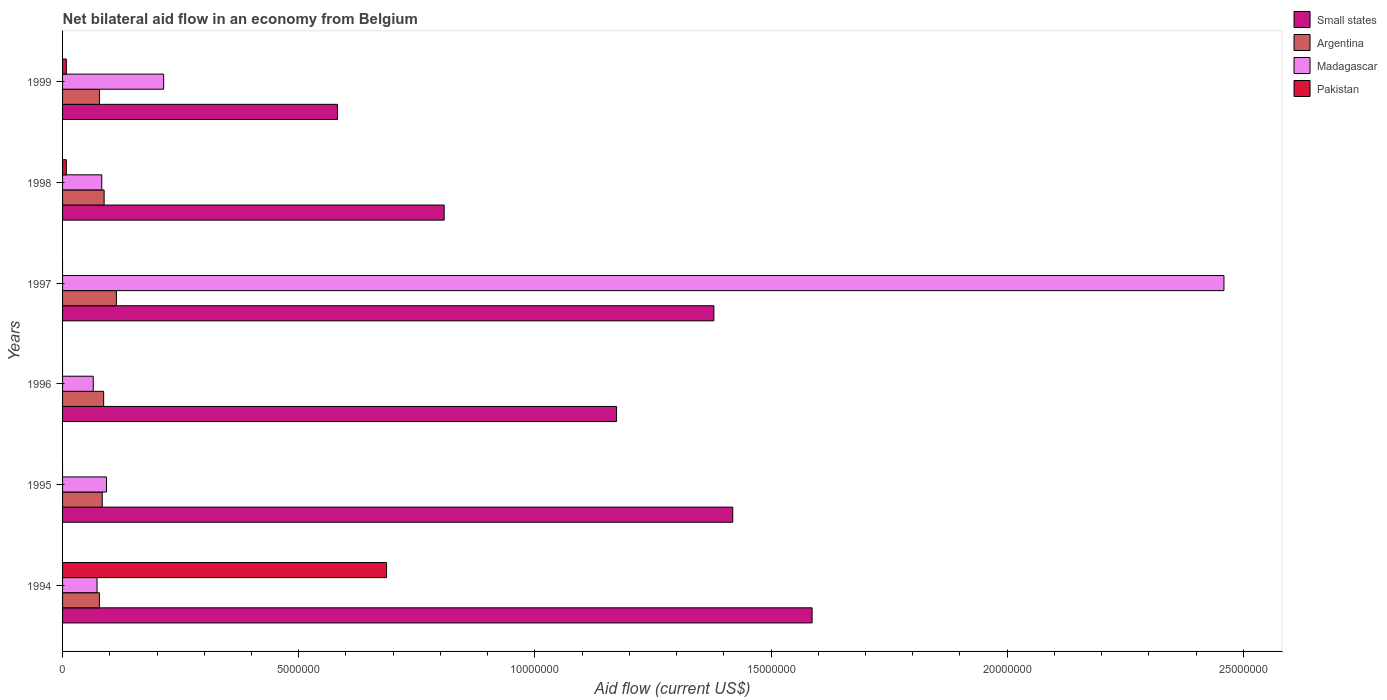How many groups of bars are there?
Your answer should be very brief. 6. How many bars are there on the 1st tick from the top?
Give a very brief answer. 4. In how many cases, is the number of bars for a given year not equal to the number of legend labels?
Make the answer very short. 3. What is the net bilateral aid flow in Argentina in 1997?
Give a very brief answer. 1.14e+06. Across all years, what is the maximum net bilateral aid flow in Madagascar?
Ensure brevity in your answer.  2.46e+07. Across all years, what is the minimum net bilateral aid flow in Madagascar?
Give a very brief answer. 6.50e+05. What is the total net bilateral aid flow in Small states in the graph?
Provide a succinct answer. 6.95e+07. What is the difference between the net bilateral aid flow in Madagascar in 1997 and that in 1998?
Offer a very short reply. 2.38e+07. What is the difference between the net bilateral aid flow in Pakistan in 1998 and the net bilateral aid flow in Argentina in 1997?
Your answer should be very brief. -1.06e+06. What is the average net bilateral aid flow in Argentina per year?
Provide a succinct answer. 8.82e+05. In the year 1994, what is the difference between the net bilateral aid flow in Madagascar and net bilateral aid flow in Argentina?
Ensure brevity in your answer.  -5.00e+04. What is the ratio of the net bilateral aid flow in Madagascar in 1997 to that in 1998?
Give a very brief answer. 29.63. Is the net bilateral aid flow in Madagascar in 1996 less than that in 1998?
Your answer should be compact. Yes. What is the difference between the highest and the second highest net bilateral aid flow in Small states?
Offer a very short reply. 1.68e+06. What is the difference between the highest and the lowest net bilateral aid flow in Small states?
Your answer should be very brief. 1.00e+07. Is the sum of the net bilateral aid flow in Small states in 1996 and 1997 greater than the maximum net bilateral aid flow in Madagascar across all years?
Ensure brevity in your answer.  Yes. How many bars are there?
Offer a terse response. 21. What is the difference between two consecutive major ticks on the X-axis?
Offer a very short reply. 5.00e+06. Does the graph contain any zero values?
Offer a very short reply. Yes. Does the graph contain grids?
Ensure brevity in your answer.  No. Where does the legend appear in the graph?
Make the answer very short. Top right. How many legend labels are there?
Keep it short and to the point. 4. How are the legend labels stacked?
Make the answer very short. Vertical. What is the title of the graph?
Your response must be concise. Net bilateral aid flow in an economy from Belgium. What is the Aid flow (current US$) of Small states in 1994?
Your response must be concise. 1.59e+07. What is the Aid flow (current US$) of Argentina in 1994?
Your answer should be very brief. 7.80e+05. What is the Aid flow (current US$) of Madagascar in 1994?
Offer a very short reply. 7.30e+05. What is the Aid flow (current US$) in Pakistan in 1994?
Make the answer very short. 6.86e+06. What is the Aid flow (current US$) of Small states in 1995?
Provide a short and direct response. 1.42e+07. What is the Aid flow (current US$) in Argentina in 1995?
Ensure brevity in your answer.  8.40e+05. What is the Aid flow (current US$) in Madagascar in 1995?
Your answer should be very brief. 9.30e+05. What is the Aid flow (current US$) in Small states in 1996?
Give a very brief answer. 1.17e+07. What is the Aid flow (current US$) in Argentina in 1996?
Provide a short and direct response. 8.70e+05. What is the Aid flow (current US$) of Madagascar in 1996?
Provide a succinct answer. 6.50e+05. What is the Aid flow (current US$) in Small states in 1997?
Give a very brief answer. 1.38e+07. What is the Aid flow (current US$) of Argentina in 1997?
Ensure brevity in your answer.  1.14e+06. What is the Aid flow (current US$) of Madagascar in 1997?
Make the answer very short. 2.46e+07. What is the Aid flow (current US$) of Pakistan in 1997?
Make the answer very short. 0. What is the Aid flow (current US$) of Small states in 1998?
Your response must be concise. 8.08e+06. What is the Aid flow (current US$) of Argentina in 1998?
Offer a very short reply. 8.80e+05. What is the Aid flow (current US$) in Madagascar in 1998?
Your answer should be very brief. 8.30e+05. What is the Aid flow (current US$) of Pakistan in 1998?
Make the answer very short. 8.00e+04. What is the Aid flow (current US$) in Small states in 1999?
Make the answer very short. 5.82e+06. What is the Aid flow (current US$) of Argentina in 1999?
Keep it short and to the point. 7.80e+05. What is the Aid flow (current US$) in Madagascar in 1999?
Ensure brevity in your answer.  2.14e+06. What is the Aid flow (current US$) of Pakistan in 1999?
Your answer should be very brief. 8.00e+04. Across all years, what is the maximum Aid flow (current US$) in Small states?
Provide a succinct answer. 1.59e+07. Across all years, what is the maximum Aid flow (current US$) of Argentina?
Offer a very short reply. 1.14e+06. Across all years, what is the maximum Aid flow (current US$) in Madagascar?
Your response must be concise. 2.46e+07. Across all years, what is the maximum Aid flow (current US$) of Pakistan?
Offer a very short reply. 6.86e+06. Across all years, what is the minimum Aid flow (current US$) in Small states?
Your answer should be very brief. 5.82e+06. Across all years, what is the minimum Aid flow (current US$) in Argentina?
Keep it short and to the point. 7.80e+05. Across all years, what is the minimum Aid flow (current US$) of Madagascar?
Offer a terse response. 6.50e+05. Across all years, what is the minimum Aid flow (current US$) of Pakistan?
Your answer should be very brief. 0. What is the total Aid flow (current US$) in Small states in the graph?
Your response must be concise. 6.95e+07. What is the total Aid flow (current US$) in Argentina in the graph?
Provide a succinct answer. 5.29e+06. What is the total Aid flow (current US$) of Madagascar in the graph?
Your response must be concise. 2.99e+07. What is the total Aid flow (current US$) in Pakistan in the graph?
Make the answer very short. 7.02e+06. What is the difference between the Aid flow (current US$) of Small states in 1994 and that in 1995?
Your answer should be very brief. 1.68e+06. What is the difference between the Aid flow (current US$) of Argentina in 1994 and that in 1995?
Your answer should be compact. -6.00e+04. What is the difference between the Aid flow (current US$) of Madagascar in 1994 and that in 1995?
Provide a succinct answer. -2.00e+05. What is the difference between the Aid flow (current US$) in Small states in 1994 and that in 1996?
Your answer should be very brief. 4.14e+06. What is the difference between the Aid flow (current US$) of Madagascar in 1994 and that in 1996?
Keep it short and to the point. 8.00e+04. What is the difference between the Aid flow (current US$) in Small states in 1994 and that in 1997?
Offer a terse response. 2.08e+06. What is the difference between the Aid flow (current US$) of Argentina in 1994 and that in 1997?
Keep it short and to the point. -3.60e+05. What is the difference between the Aid flow (current US$) of Madagascar in 1994 and that in 1997?
Your answer should be compact. -2.39e+07. What is the difference between the Aid flow (current US$) in Small states in 1994 and that in 1998?
Make the answer very short. 7.79e+06. What is the difference between the Aid flow (current US$) of Argentina in 1994 and that in 1998?
Give a very brief answer. -1.00e+05. What is the difference between the Aid flow (current US$) of Pakistan in 1994 and that in 1998?
Provide a succinct answer. 6.78e+06. What is the difference between the Aid flow (current US$) of Small states in 1994 and that in 1999?
Ensure brevity in your answer.  1.00e+07. What is the difference between the Aid flow (current US$) of Madagascar in 1994 and that in 1999?
Your answer should be compact. -1.41e+06. What is the difference between the Aid flow (current US$) of Pakistan in 1994 and that in 1999?
Provide a short and direct response. 6.78e+06. What is the difference between the Aid flow (current US$) of Small states in 1995 and that in 1996?
Ensure brevity in your answer.  2.46e+06. What is the difference between the Aid flow (current US$) in Madagascar in 1995 and that in 1996?
Your response must be concise. 2.80e+05. What is the difference between the Aid flow (current US$) of Small states in 1995 and that in 1997?
Offer a very short reply. 4.00e+05. What is the difference between the Aid flow (current US$) in Madagascar in 1995 and that in 1997?
Provide a short and direct response. -2.37e+07. What is the difference between the Aid flow (current US$) of Small states in 1995 and that in 1998?
Your answer should be very brief. 6.11e+06. What is the difference between the Aid flow (current US$) of Madagascar in 1995 and that in 1998?
Provide a succinct answer. 1.00e+05. What is the difference between the Aid flow (current US$) in Small states in 1995 and that in 1999?
Make the answer very short. 8.37e+06. What is the difference between the Aid flow (current US$) in Madagascar in 1995 and that in 1999?
Make the answer very short. -1.21e+06. What is the difference between the Aid flow (current US$) of Small states in 1996 and that in 1997?
Your answer should be compact. -2.06e+06. What is the difference between the Aid flow (current US$) of Argentina in 1996 and that in 1997?
Provide a succinct answer. -2.70e+05. What is the difference between the Aid flow (current US$) in Madagascar in 1996 and that in 1997?
Your answer should be compact. -2.39e+07. What is the difference between the Aid flow (current US$) of Small states in 1996 and that in 1998?
Give a very brief answer. 3.65e+06. What is the difference between the Aid flow (current US$) of Argentina in 1996 and that in 1998?
Ensure brevity in your answer.  -10000. What is the difference between the Aid flow (current US$) of Madagascar in 1996 and that in 1998?
Ensure brevity in your answer.  -1.80e+05. What is the difference between the Aid flow (current US$) in Small states in 1996 and that in 1999?
Give a very brief answer. 5.91e+06. What is the difference between the Aid flow (current US$) in Argentina in 1996 and that in 1999?
Ensure brevity in your answer.  9.00e+04. What is the difference between the Aid flow (current US$) of Madagascar in 1996 and that in 1999?
Your response must be concise. -1.49e+06. What is the difference between the Aid flow (current US$) in Small states in 1997 and that in 1998?
Offer a very short reply. 5.71e+06. What is the difference between the Aid flow (current US$) in Argentina in 1997 and that in 1998?
Keep it short and to the point. 2.60e+05. What is the difference between the Aid flow (current US$) of Madagascar in 1997 and that in 1998?
Your answer should be very brief. 2.38e+07. What is the difference between the Aid flow (current US$) in Small states in 1997 and that in 1999?
Offer a terse response. 7.97e+06. What is the difference between the Aid flow (current US$) in Argentina in 1997 and that in 1999?
Keep it short and to the point. 3.60e+05. What is the difference between the Aid flow (current US$) in Madagascar in 1997 and that in 1999?
Your answer should be compact. 2.24e+07. What is the difference between the Aid flow (current US$) in Small states in 1998 and that in 1999?
Keep it short and to the point. 2.26e+06. What is the difference between the Aid flow (current US$) in Argentina in 1998 and that in 1999?
Provide a short and direct response. 1.00e+05. What is the difference between the Aid flow (current US$) in Madagascar in 1998 and that in 1999?
Make the answer very short. -1.31e+06. What is the difference between the Aid flow (current US$) of Small states in 1994 and the Aid flow (current US$) of Argentina in 1995?
Give a very brief answer. 1.50e+07. What is the difference between the Aid flow (current US$) in Small states in 1994 and the Aid flow (current US$) in Madagascar in 1995?
Your answer should be very brief. 1.49e+07. What is the difference between the Aid flow (current US$) of Argentina in 1994 and the Aid flow (current US$) of Madagascar in 1995?
Provide a succinct answer. -1.50e+05. What is the difference between the Aid flow (current US$) in Small states in 1994 and the Aid flow (current US$) in Argentina in 1996?
Provide a short and direct response. 1.50e+07. What is the difference between the Aid flow (current US$) in Small states in 1994 and the Aid flow (current US$) in Madagascar in 1996?
Ensure brevity in your answer.  1.52e+07. What is the difference between the Aid flow (current US$) in Argentina in 1994 and the Aid flow (current US$) in Madagascar in 1996?
Make the answer very short. 1.30e+05. What is the difference between the Aid flow (current US$) of Small states in 1994 and the Aid flow (current US$) of Argentina in 1997?
Offer a terse response. 1.47e+07. What is the difference between the Aid flow (current US$) in Small states in 1994 and the Aid flow (current US$) in Madagascar in 1997?
Provide a short and direct response. -8.72e+06. What is the difference between the Aid flow (current US$) of Argentina in 1994 and the Aid flow (current US$) of Madagascar in 1997?
Offer a very short reply. -2.38e+07. What is the difference between the Aid flow (current US$) of Small states in 1994 and the Aid flow (current US$) of Argentina in 1998?
Your response must be concise. 1.50e+07. What is the difference between the Aid flow (current US$) in Small states in 1994 and the Aid flow (current US$) in Madagascar in 1998?
Your answer should be very brief. 1.50e+07. What is the difference between the Aid flow (current US$) of Small states in 1994 and the Aid flow (current US$) of Pakistan in 1998?
Provide a short and direct response. 1.58e+07. What is the difference between the Aid flow (current US$) in Argentina in 1994 and the Aid flow (current US$) in Madagascar in 1998?
Your answer should be compact. -5.00e+04. What is the difference between the Aid flow (current US$) in Argentina in 1994 and the Aid flow (current US$) in Pakistan in 1998?
Offer a terse response. 7.00e+05. What is the difference between the Aid flow (current US$) of Madagascar in 1994 and the Aid flow (current US$) of Pakistan in 1998?
Give a very brief answer. 6.50e+05. What is the difference between the Aid flow (current US$) of Small states in 1994 and the Aid flow (current US$) of Argentina in 1999?
Your response must be concise. 1.51e+07. What is the difference between the Aid flow (current US$) in Small states in 1994 and the Aid flow (current US$) in Madagascar in 1999?
Offer a very short reply. 1.37e+07. What is the difference between the Aid flow (current US$) in Small states in 1994 and the Aid flow (current US$) in Pakistan in 1999?
Your answer should be compact. 1.58e+07. What is the difference between the Aid flow (current US$) in Argentina in 1994 and the Aid flow (current US$) in Madagascar in 1999?
Provide a short and direct response. -1.36e+06. What is the difference between the Aid flow (current US$) in Argentina in 1994 and the Aid flow (current US$) in Pakistan in 1999?
Give a very brief answer. 7.00e+05. What is the difference between the Aid flow (current US$) in Madagascar in 1994 and the Aid flow (current US$) in Pakistan in 1999?
Provide a succinct answer. 6.50e+05. What is the difference between the Aid flow (current US$) in Small states in 1995 and the Aid flow (current US$) in Argentina in 1996?
Provide a succinct answer. 1.33e+07. What is the difference between the Aid flow (current US$) in Small states in 1995 and the Aid flow (current US$) in Madagascar in 1996?
Keep it short and to the point. 1.35e+07. What is the difference between the Aid flow (current US$) in Argentina in 1995 and the Aid flow (current US$) in Madagascar in 1996?
Give a very brief answer. 1.90e+05. What is the difference between the Aid flow (current US$) of Small states in 1995 and the Aid flow (current US$) of Argentina in 1997?
Provide a short and direct response. 1.30e+07. What is the difference between the Aid flow (current US$) in Small states in 1995 and the Aid flow (current US$) in Madagascar in 1997?
Provide a short and direct response. -1.04e+07. What is the difference between the Aid flow (current US$) of Argentina in 1995 and the Aid flow (current US$) of Madagascar in 1997?
Your answer should be very brief. -2.38e+07. What is the difference between the Aid flow (current US$) of Small states in 1995 and the Aid flow (current US$) of Argentina in 1998?
Your answer should be compact. 1.33e+07. What is the difference between the Aid flow (current US$) of Small states in 1995 and the Aid flow (current US$) of Madagascar in 1998?
Make the answer very short. 1.34e+07. What is the difference between the Aid flow (current US$) in Small states in 1995 and the Aid flow (current US$) in Pakistan in 1998?
Provide a short and direct response. 1.41e+07. What is the difference between the Aid flow (current US$) in Argentina in 1995 and the Aid flow (current US$) in Pakistan in 1998?
Your response must be concise. 7.60e+05. What is the difference between the Aid flow (current US$) in Madagascar in 1995 and the Aid flow (current US$) in Pakistan in 1998?
Give a very brief answer. 8.50e+05. What is the difference between the Aid flow (current US$) of Small states in 1995 and the Aid flow (current US$) of Argentina in 1999?
Ensure brevity in your answer.  1.34e+07. What is the difference between the Aid flow (current US$) of Small states in 1995 and the Aid flow (current US$) of Madagascar in 1999?
Ensure brevity in your answer.  1.20e+07. What is the difference between the Aid flow (current US$) in Small states in 1995 and the Aid flow (current US$) in Pakistan in 1999?
Keep it short and to the point. 1.41e+07. What is the difference between the Aid flow (current US$) of Argentina in 1995 and the Aid flow (current US$) of Madagascar in 1999?
Your answer should be compact. -1.30e+06. What is the difference between the Aid flow (current US$) of Argentina in 1995 and the Aid flow (current US$) of Pakistan in 1999?
Make the answer very short. 7.60e+05. What is the difference between the Aid flow (current US$) of Madagascar in 1995 and the Aid flow (current US$) of Pakistan in 1999?
Offer a terse response. 8.50e+05. What is the difference between the Aid flow (current US$) of Small states in 1996 and the Aid flow (current US$) of Argentina in 1997?
Ensure brevity in your answer.  1.06e+07. What is the difference between the Aid flow (current US$) of Small states in 1996 and the Aid flow (current US$) of Madagascar in 1997?
Your response must be concise. -1.29e+07. What is the difference between the Aid flow (current US$) in Argentina in 1996 and the Aid flow (current US$) in Madagascar in 1997?
Your answer should be compact. -2.37e+07. What is the difference between the Aid flow (current US$) of Small states in 1996 and the Aid flow (current US$) of Argentina in 1998?
Keep it short and to the point. 1.08e+07. What is the difference between the Aid flow (current US$) of Small states in 1996 and the Aid flow (current US$) of Madagascar in 1998?
Offer a very short reply. 1.09e+07. What is the difference between the Aid flow (current US$) of Small states in 1996 and the Aid flow (current US$) of Pakistan in 1998?
Your response must be concise. 1.16e+07. What is the difference between the Aid flow (current US$) in Argentina in 1996 and the Aid flow (current US$) in Madagascar in 1998?
Offer a very short reply. 4.00e+04. What is the difference between the Aid flow (current US$) of Argentina in 1996 and the Aid flow (current US$) of Pakistan in 1998?
Provide a succinct answer. 7.90e+05. What is the difference between the Aid flow (current US$) in Madagascar in 1996 and the Aid flow (current US$) in Pakistan in 1998?
Your answer should be very brief. 5.70e+05. What is the difference between the Aid flow (current US$) in Small states in 1996 and the Aid flow (current US$) in Argentina in 1999?
Give a very brief answer. 1.10e+07. What is the difference between the Aid flow (current US$) of Small states in 1996 and the Aid flow (current US$) of Madagascar in 1999?
Ensure brevity in your answer.  9.59e+06. What is the difference between the Aid flow (current US$) in Small states in 1996 and the Aid flow (current US$) in Pakistan in 1999?
Your answer should be compact. 1.16e+07. What is the difference between the Aid flow (current US$) of Argentina in 1996 and the Aid flow (current US$) of Madagascar in 1999?
Ensure brevity in your answer.  -1.27e+06. What is the difference between the Aid flow (current US$) of Argentina in 1996 and the Aid flow (current US$) of Pakistan in 1999?
Your answer should be very brief. 7.90e+05. What is the difference between the Aid flow (current US$) in Madagascar in 1996 and the Aid flow (current US$) in Pakistan in 1999?
Provide a succinct answer. 5.70e+05. What is the difference between the Aid flow (current US$) of Small states in 1997 and the Aid flow (current US$) of Argentina in 1998?
Give a very brief answer. 1.29e+07. What is the difference between the Aid flow (current US$) in Small states in 1997 and the Aid flow (current US$) in Madagascar in 1998?
Provide a short and direct response. 1.30e+07. What is the difference between the Aid flow (current US$) in Small states in 1997 and the Aid flow (current US$) in Pakistan in 1998?
Provide a short and direct response. 1.37e+07. What is the difference between the Aid flow (current US$) of Argentina in 1997 and the Aid flow (current US$) of Madagascar in 1998?
Provide a short and direct response. 3.10e+05. What is the difference between the Aid flow (current US$) in Argentina in 1997 and the Aid flow (current US$) in Pakistan in 1998?
Keep it short and to the point. 1.06e+06. What is the difference between the Aid flow (current US$) of Madagascar in 1997 and the Aid flow (current US$) of Pakistan in 1998?
Keep it short and to the point. 2.45e+07. What is the difference between the Aid flow (current US$) of Small states in 1997 and the Aid flow (current US$) of Argentina in 1999?
Your answer should be very brief. 1.30e+07. What is the difference between the Aid flow (current US$) of Small states in 1997 and the Aid flow (current US$) of Madagascar in 1999?
Give a very brief answer. 1.16e+07. What is the difference between the Aid flow (current US$) in Small states in 1997 and the Aid flow (current US$) in Pakistan in 1999?
Your answer should be compact. 1.37e+07. What is the difference between the Aid flow (current US$) in Argentina in 1997 and the Aid flow (current US$) in Pakistan in 1999?
Ensure brevity in your answer.  1.06e+06. What is the difference between the Aid flow (current US$) in Madagascar in 1997 and the Aid flow (current US$) in Pakistan in 1999?
Give a very brief answer. 2.45e+07. What is the difference between the Aid flow (current US$) of Small states in 1998 and the Aid flow (current US$) of Argentina in 1999?
Offer a terse response. 7.30e+06. What is the difference between the Aid flow (current US$) in Small states in 1998 and the Aid flow (current US$) in Madagascar in 1999?
Give a very brief answer. 5.94e+06. What is the difference between the Aid flow (current US$) in Small states in 1998 and the Aid flow (current US$) in Pakistan in 1999?
Offer a terse response. 8.00e+06. What is the difference between the Aid flow (current US$) in Argentina in 1998 and the Aid flow (current US$) in Madagascar in 1999?
Make the answer very short. -1.26e+06. What is the difference between the Aid flow (current US$) of Argentina in 1998 and the Aid flow (current US$) of Pakistan in 1999?
Give a very brief answer. 8.00e+05. What is the difference between the Aid flow (current US$) in Madagascar in 1998 and the Aid flow (current US$) in Pakistan in 1999?
Offer a terse response. 7.50e+05. What is the average Aid flow (current US$) of Small states per year?
Provide a succinct answer. 1.16e+07. What is the average Aid flow (current US$) in Argentina per year?
Your answer should be compact. 8.82e+05. What is the average Aid flow (current US$) in Madagascar per year?
Keep it short and to the point. 4.98e+06. What is the average Aid flow (current US$) in Pakistan per year?
Offer a terse response. 1.17e+06. In the year 1994, what is the difference between the Aid flow (current US$) in Small states and Aid flow (current US$) in Argentina?
Your answer should be very brief. 1.51e+07. In the year 1994, what is the difference between the Aid flow (current US$) of Small states and Aid flow (current US$) of Madagascar?
Keep it short and to the point. 1.51e+07. In the year 1994, what is the difference between the Aid flow (current US$) in Small states and Aid flow (current US$) in Pakistan?
Your answer should be compact. 9.01e+06. In the year 1994, what is the difference between the Aid flow (current US$) of Argentina and Aid flow (current US$) of Madagascar?
Offer a very short reply. 5.00e+04. In the year 1994, what is the difference between the Aid flow (current US$) in Argentina and Aid flow (current US$) in Pakistan?
Provide a succinct answer. -6.08e+06. In the year 1994, what is the difference between the Aid flow (current US$) of Madagascar and Aid flow (current US$) of Pakistan?
Make the answer very short. -6.13e+06. In the year 1995, what is the difference between the Aid flow (current US$) in Small states and Aid flow (current US$) in Argentina?
Your answer should be compact. 1.34e+07. In the year 1995, what is the difference between the Aid flow (current US$) in Small states and Aid flow (current US$) in Madagascar?
Make the answer very short. 1.33e+07. In the year 1996, what is the difference between the Aid flow (current US$) in Small states and Aid flow (current US$) in Argentina?
Your answer should be compact. 1.09e+07. In the year 1996, what is the difference between the Aid flow (current US$) in Small states and Aid flow (current US$) in Madagascar?
Keep it short and to the point. 1.11e+07. In the year 1996, what is the difference between the Aid flow (current US$) in Argentina and Aid flow (current US$) in Madagascar?
Keep it short and to the point. 2.20e+05. In the year 1997, what is the difference between the Aid flow (current US$) of Small states and Aid flow (current US$) of Argentina?
Provide a succinct answer. 1.26e+07. In the year 1997, what is the difference between the Aid flow (current US$) of Small states and Aid flow (current US$) of Madagascar?
Your answer should be compact. -1.08e+07. In the year 1997, what is the difference between the Aid flow (current US$) of Argentina and Aid flow (current US$) of Madagascar?
Your answer should be very brief. -2.34e+07. In the year 1998, what is the difference between the Aid flow (current US$) of Small states and Aid flow (current US$) of Argentina?
Your answer should be compact. 7.20e+06. In the year 1998, what is the difference between the Aid flow (current US$) of Small states and Aid flow (current US$) of Madagascar?
Ensure brevity in your answer.  7.25e+06. In the year 1998, what is the difference between the Aid flow (current US$) of Argentina and Aid flow (current US$) of Pakistan?
Offer a very short reply. 8.00e+05. In the year 1998, what is the difference between the Aid flow (current US$) in Madagascar and Aid flow (current US$) in Pakistan?
Make the answer very short. 7.50e+05. In the year 1999, what is the difference between the Aid flow (current US$) in Small states and Aid flow (current US$) in Argentina?
Provide a succinct answer. 5.04e+06. In the year 1999, what is the difference between the Aid flow (current US$) of Small states and Aid flow (current US$) of Madagascar?
Offer a very short reply. 3.68e+06. In the year 1999, what is the difference between the Aid flow (current US$) in Small states and Aid flow (current US$) in Pakistan?
Provide a short and direct response. 5.74e+06. In the year 1999, what is the difference between the Aid flow (current US$) of Argentina and Aid flow (current US$) of Madagascar?
Offer a very short reply. -1.36e+06. In the year 1999, what is the difference between the Aid flow (current US$) of Argentina and Aid flow (current US$) of Pakistan?
Your response must be concise. 7.00e+05. In the year 1999, what is the difference between the Aid flow (current US$) in Madagascar and Aid flow (current US$) in Pakistan?
Provide a short and direct response. 2.06e+06. What is the ratio of the Aid flow (current US$) of Small states in 1994 to that in 1995?
Make the answer very short. 1.12. What is the ratio of the Aid flow (current US$) of Madagascar in 1994 to that in 1995?
Provide a short and direct response. 0.78. What is the ratio of the Aid flow (current US$) of Small states in 1994 to that in 1996?
Provide a short and direct response. 1.35. What is the ratio of the Aid flow (current US$) in Argentina in 1994 to that in 1996?
Provide a succinct answer. 0.9. What is the ratio of the Aid flow (current US$) of Madagascar in 1994 to that in 1996?
Provide a succinct answer. 1.12. What is the ratio of the Aid flow (current US$) of Small states in 1994 to that in 1997?
Offer a very short reply. 1.15. What is the ratio of the Aid flow (current US$) in Argentina in 1994 to that in 1997?
Give a very brief answer. 0.68. What is the ratio of the Aid flow (current US$) in Madagascar in 1994 to that in 1997?
Offer a terse response. 0.03. What is the ratio of the Aid flow (current US$) of Small states in 1994 to that in 1998?
Your response must be concise. 1.96. What is the ratio of the Aid flow (current US$) of Argentina in 1994 to that in 1998?
Your response must be concise. 0.89. What is the ratio of the Aid flow (current US$) of Madagascar in 1994 to that in 1998?
Provide a short and direct response. 0.88. What is the ratio of the Aid flow (current US$) of Pakistan in 1994 to that in 1998?
Keep it short and to the point. 85.75. What is the ratio of the Aid flow (current US$) in Small states in 1994 to that in 1999?
Offer a terse response. 2.73. What is the ratio of the Aid flow (current US$) of Madagascar in 1994 to that in 1999?
Give a very brief answer. 0.34. What is the ratio of the Aid flow (current US$) in Pakistan in 1994 to that in 1999?
Your answer should be compact. 85.75. What is the ratio of the Aid flow (current US$) in Small states in 1995 to that in 1996?
Your answer should be compact. 1.21. What is the ratio of the Aid flow (current US$) of Argentina in 1995 to that in 1996?
Offer a terse response. 0.97. What is the ratio of the Aid flow (current US$) of Madagascar in 1995 to that in 1996?
Provide a short and direct response. 1.43. What is the ratio of the Aid flow (current US$) of Small states in 1995 to that in 1997?
Offer a very short reply. 1.03. What is the ratio of the Aid flow (current US$) of Argentina in 1995 to that in 1997?
Provide a short and direct response. 0.74. What is the ratio of the Aid flow (current US$) in Madagascar in 1995 to that in 1997?
Offer a terse response. 0.04. What is the ratio of the Aid flow (current US$) of Small states in 1995 to that in 1998?
Provide a succinct answer. 1.76. What is the ratio of the Aid flow (current US$) in Argentina in 1995 to that in 1998?
Your answer should be compact. 0.95. What is the ratio of the Aid flow (current US$) in Madagascar in 1995 to that in 1998?
Your response must be concise. 1.12. What is the ratio of the Aid flow (current US$) of Small states in 1995 to that in 1999?
Your answer should be very brief. 2.44. What is the ratio of the Aid flow (current US$) of Argentina in 1995 to that in 1999?
Ensure brevity in your answer.  1.08. What is the ratio of the Aid flow (current US$) in Madagascar in 1995 to that in 1999?
Make the answer very short. 0.43. What is the ratio of the Aid flow (current US$) in Small states in 1996 to that in 1997?
Your response must be concise. 0.85. What is the ratio of the Aid flow (current US$) in Argentina in 1996 to that in 1997?
Your response must be concise. 0.76. What is the ratio of the Aid flow (current US$) in Madagascar in 1996 to that in 1997?
Offer a very short reply. 0.03. What is the ratio of the Aid flow (current US$) in Small states in 1996 to that in 1998?
Your response must be concise. 1.45. What is the ratio of the Aid flow (current US$) in Madagascar in 1996 to that in 1998?
Make the answer very short. 0.78. What is the ratio of the Aid flow (current US$) in Small states in 1996 to that in 1999?
Your answer should be compact. 2.02. What is the ratio of the Aid flow (current US$) of Argentina in 1996 to that in 1999?
Your answer should be compact. 1.12. What is the ratio of the Aid flow (current US$) of Madagascar in 1996 to that in 1999?
Keep it short and to the point. 0.3. What is the ratio of the Aid flow (current US$) of Small states in 1997 to that in 1998?
Your response must be concise. 1.71. What is the ratio of the Aid flow (current US$) in Argentina in 1997 to that in 1998?
Your response must be concise. 1.3. What is the ratio of the Aid flow (current US$) of Madagascar in 1997 to that in 1998?
Give a very brief answer. 29.63. What is the ratio of the Aid flow (current US$) in Small states in 1997 to that in 1999?
Give a very brief answer. 2.37. What is the ratio of the Aid flow (current US$) in Argentina in 1997 to that in 1999?
Keep it short and to the point. 1.46. What is the ratio of the Aid flow (current US$) of Madagascar in 1997 to that in 1999?
Offer a terse response. 11.49. What is the ratio of the Aid flow (current US$) of Small states in 1998 to that in 1999?
Offer a terse response. 1.39. What is the ratio of the Aid flow (current US$) in Argentina in 1998 to that in 1999?
Make the answer very short. 1.13. What is the ratio of the Aid flow (current US$) of Madagascar in 1998 to that in 1999?
Provide a short and direct response. 0.39. What is the difference between the highest and the second highest Aid flow (current US$) in Small states?
Give a very brief answer. 1.68e+06. What is the difference between the highest and the second highest Aid flow (current US$) of Argentina?
Keep it short and to the point. 2.60e+05. What is the difference between the highest and the second highest Aid flow (current US$) of Madagascar?
Keep it short and to the point. 2.24e+07. What is the difference between the highest and the second highest Aid flow (current US$) of Pakistan?
Keep it short and to the point. 6.78e+06. What is the difference between the highest and the lowest Aid flow (current US$) of Small states?
Provide a succinct answer. 1.00e+07. What is the difference between the highest and the lowest Aid flow (current US$) in Madagascar?
Give a very brief answer. 2.39e+07. What is the difference between the highest and the lowest Aid flow (current US$) of Pakistan?
Ensure brevity in your answer.  6.86e+06. 